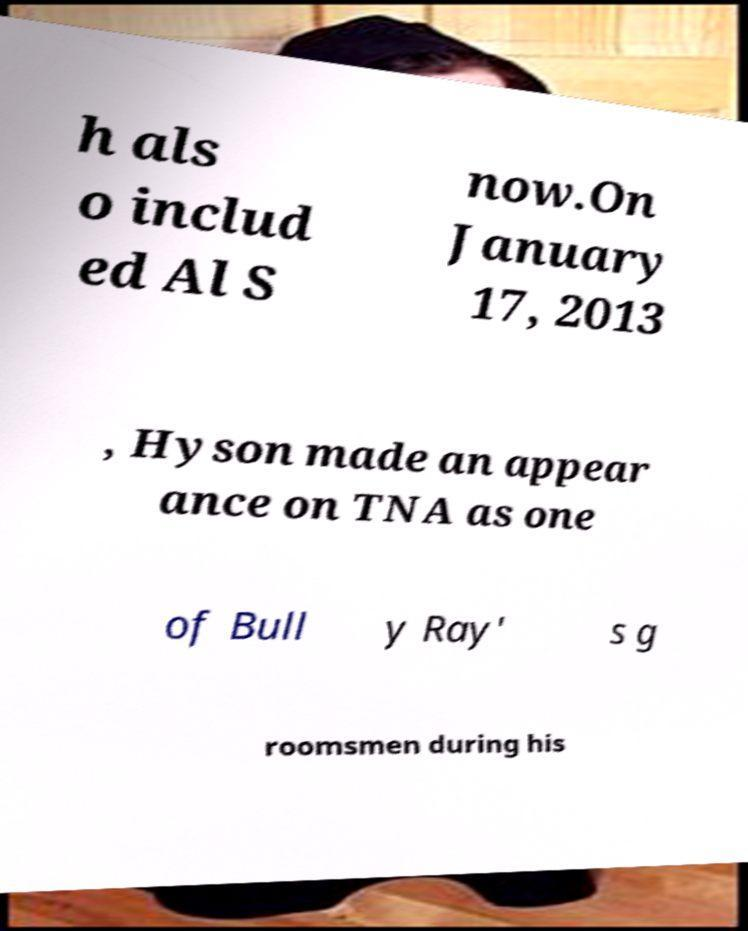Please identify and transcribe the text found in this image. h als o includ ed Al S now.On January 17, 2013 , Hyson made an appear ance on TNA as one of Bull y Ray' s g roomsmen during his 